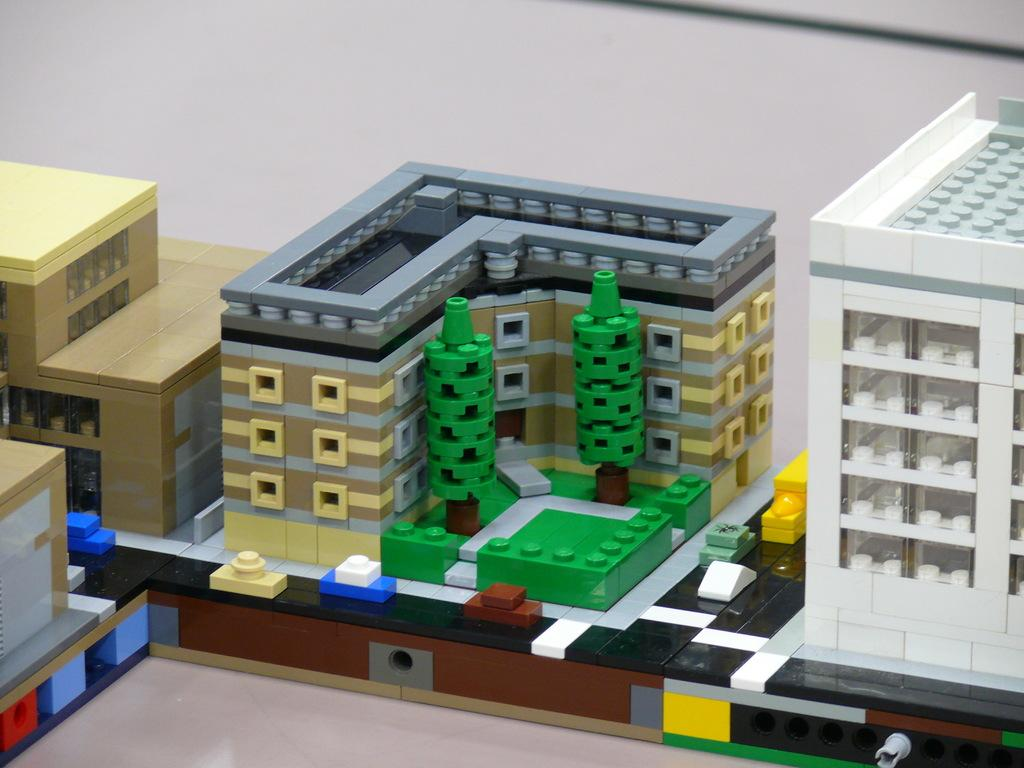What type of objects are present in the image? There are toy buildings in the image. What type of quill can be seen writing on the toy buildings in the image? There is no quill present in the image, and the toy buildings are not being written on. 